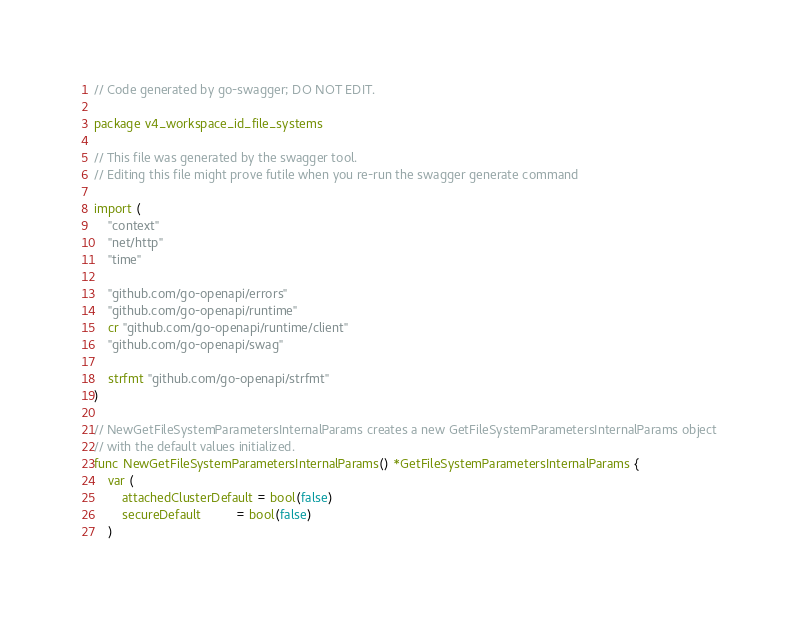Convert code to text. <code><loc_0><loc_0><loc_500><loc_500><_Go_>// Code generated by go-swagger; DO NOT EDIT.

package v4_workspace_id_file_systems

// This file was generated by the swagger tool.
// Editing this file might prove futile when you re-run the swagger generate command

import (
	"context"
	"net/http"
	"time"

	"github.com/go-openapi/errors"
	"github.com/go-openapi/runtime"
	cr "github.com/go-openapi/runtime/client"
	"github.com/go-openapi/swag"

	strfmt "github.com/go-openapi/strfmt"
)

// NewGetFileSystemParametersInternalParams creates a new GetFileSystemParametersInternalParams object
// with the default values initialized.
func NewGetFileSystemParametersInternalParams() *GetFileSystemParametersInternalParams {
	var (
		attachedClusterDefault = bool(false)
		secureDefault          = bool(false)
	)</code> 